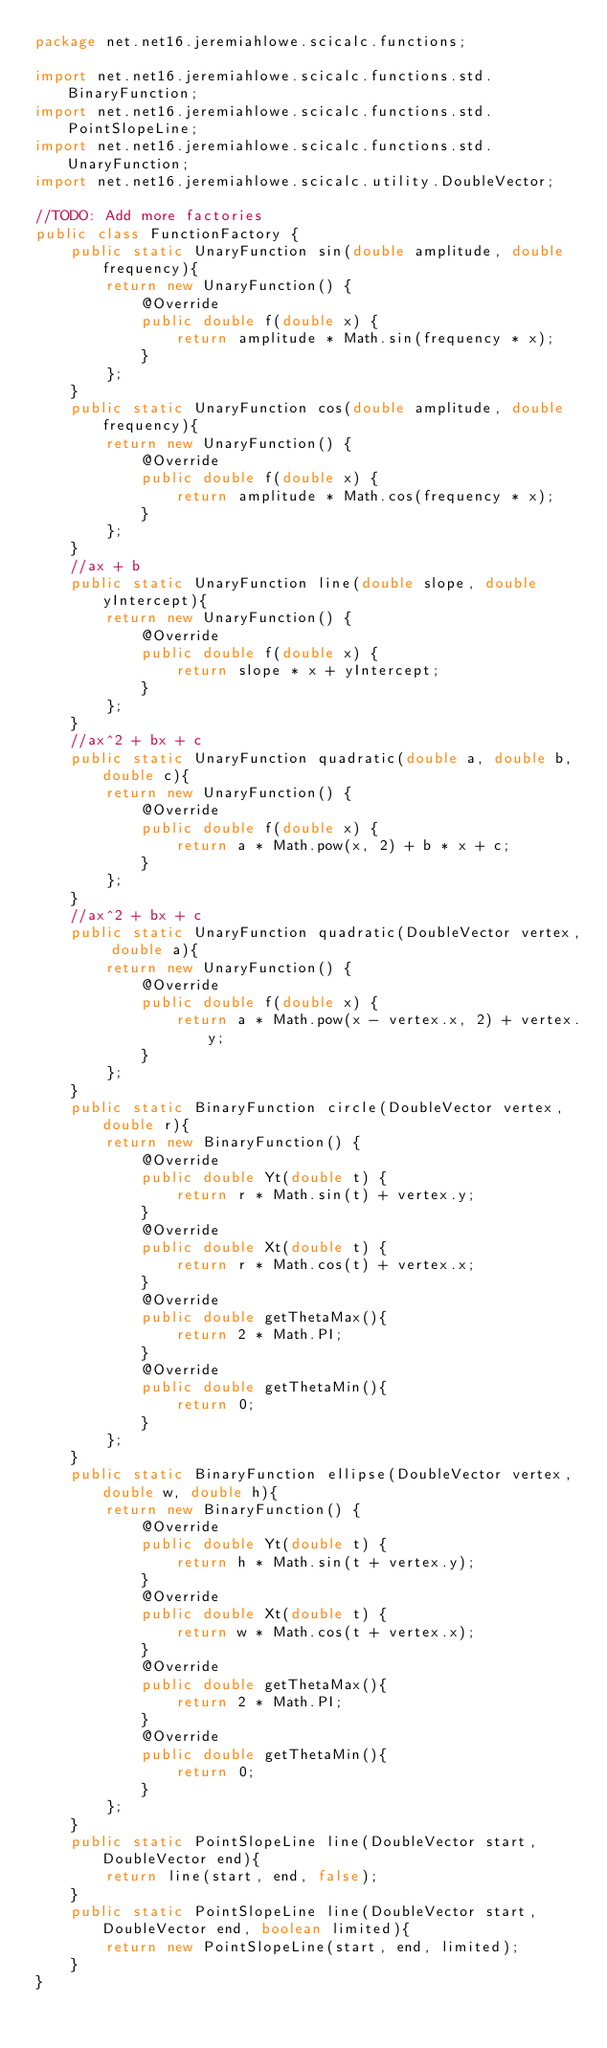Convert code to text. <code><loc_0><loc_0><loc_500><loc_500><_Java_>package net.net16.jeremiahlowe.scicalc.functions;

import net.net16.jeremiahlowe.scicalc.functions.std.BinaryFunction;
import net.net16.jeremiahlowe.scicalc.functions.std.PointSlopeLine;
import net.net16.jeremiahlowe.scicalc.functions.std.UnaryFunction;
import net.net16.jeremiahlowe.scicalc.utility.DoubleVector;

//TODO: Add more factories
public class FunctionFactory {
	public static UnaryFunction sin(double amplitude, double frequency){
		return new UnaryFunction() {
			@Override
			public double f(double x) {
				return amplitude * Math.sin(frequency * x);
			}
		};
	}
	public static UnaryFunction cos(double amplitude, double frequency){
		return new UnaryFunction() {
			@Override
			public double f(double x) {
				return amplitude * Math.cos(frequency * x);
			}
		};
	}
	//ax + b
	public static UnaryFunction line(double slope, double yIntercept){
		return new UnaryFunction() {
			@Override
			public double f(double x) {
				return slope * x + yIntercept;
			}
		};
	}
	//ax^2 + bx + c
	public static UnaryFunction quadratic(double a, double b, double c){
		return new UnaryFunction() {
			@Override
			public double f(double x) {
				return a * Math.pow(x, 2) + b * x + c;
			}
		};
	}
	//ax^2 + bx + c
	public static UnaryFunction quadratic(DoubleVector vertex, double a){
		return new UnaryFunction() {
			@Override
			public double f(double x) {
				return a * Math.pow(x - vertex.x, 2) + vertex.y;
			}
		};
	}
	public static BinaryFunction circle(DoubleVector vertex, double r){
		return new BinaryFunction() {
			@Override
			public double Yt(double t) {
				return r * Math.sin(t) + vertex.y;
			}
			@Override
			public double Xt(double t) {
				return r * Math.cos(t) + vertex.x;
			}
			@Override
			public double getThetaMax(){
				return 2 * Math.PI;
			}
			@Override
			public double getThetaMin(){
				return 0;
			}
		};
	}
	public static BinaryFunction ellipse(DoubleVector vertex, double w, double h){
		return new BinaryFunction() {
			@Override
			public double Yt(double t) {
				return h * Math.sin(t + vertex.y);
			}
			@Override
			public double Xt(double t) {
				return w * Math.cos(t + vertex.x);
			}
			@Override
			public double getThetaMax(){
				return 2 * Math.PI;
			}
			@Override
			public double getThetaMin(){
				return 0;
			}
		};
	}
	public static PointSlopeLine line(DoubleVector start, DoubleVector end){
		return line(start, end, false);
	}
	public static PointSlopeLine line(DoubleVector start, DoubleVector end, boolean limited){
		return new PointSlopeLine(start, end, limited);
	}
}
</code> 